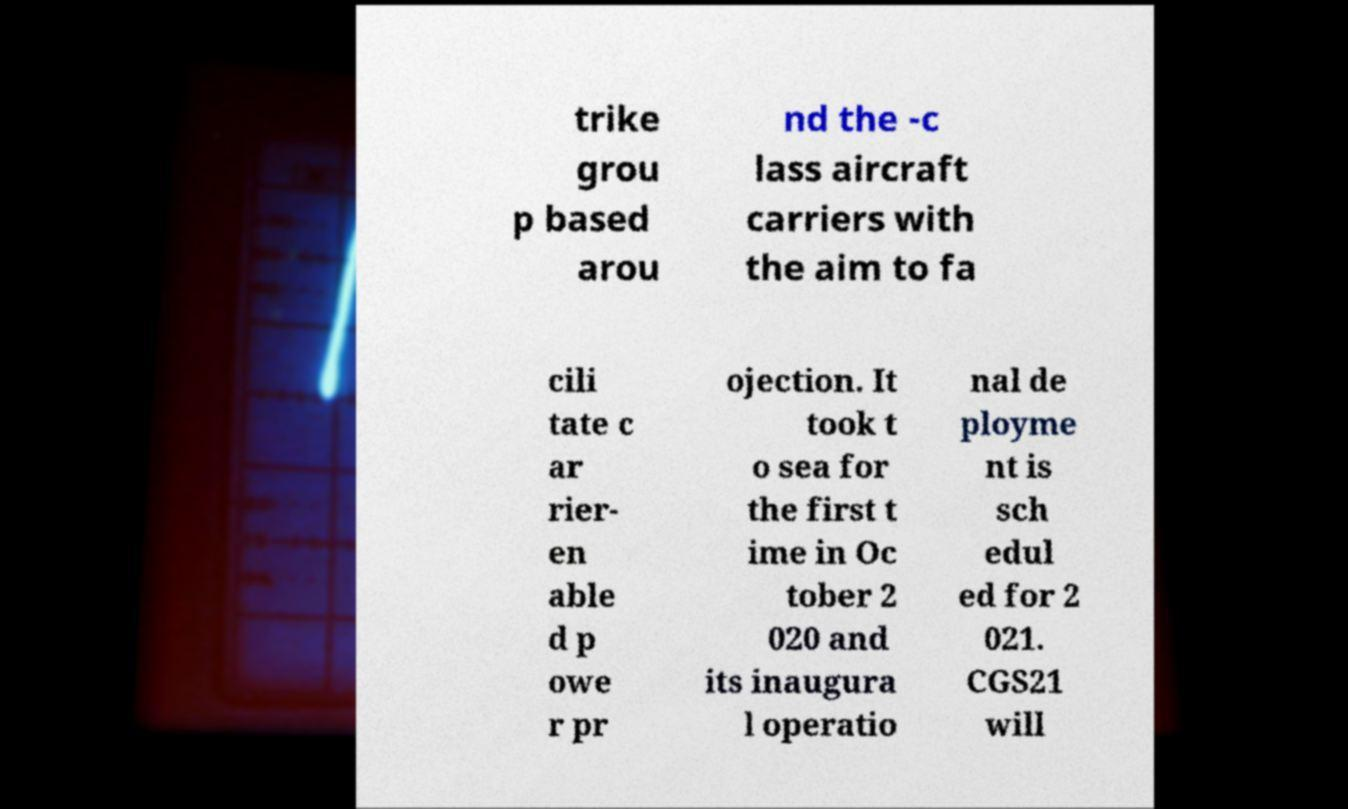Could you extract and type out the text from this image? trike grou p based arou nd the -c lass aircraft carriers with the aim to fa cili tate c ar rier- en able d p owe r pr ojection. It took t o sea for the first t ime in Oc tober 2 020 and its inaugura l operatio nal de ployme nt is sch edul ed for 2 021. CGS21 will 